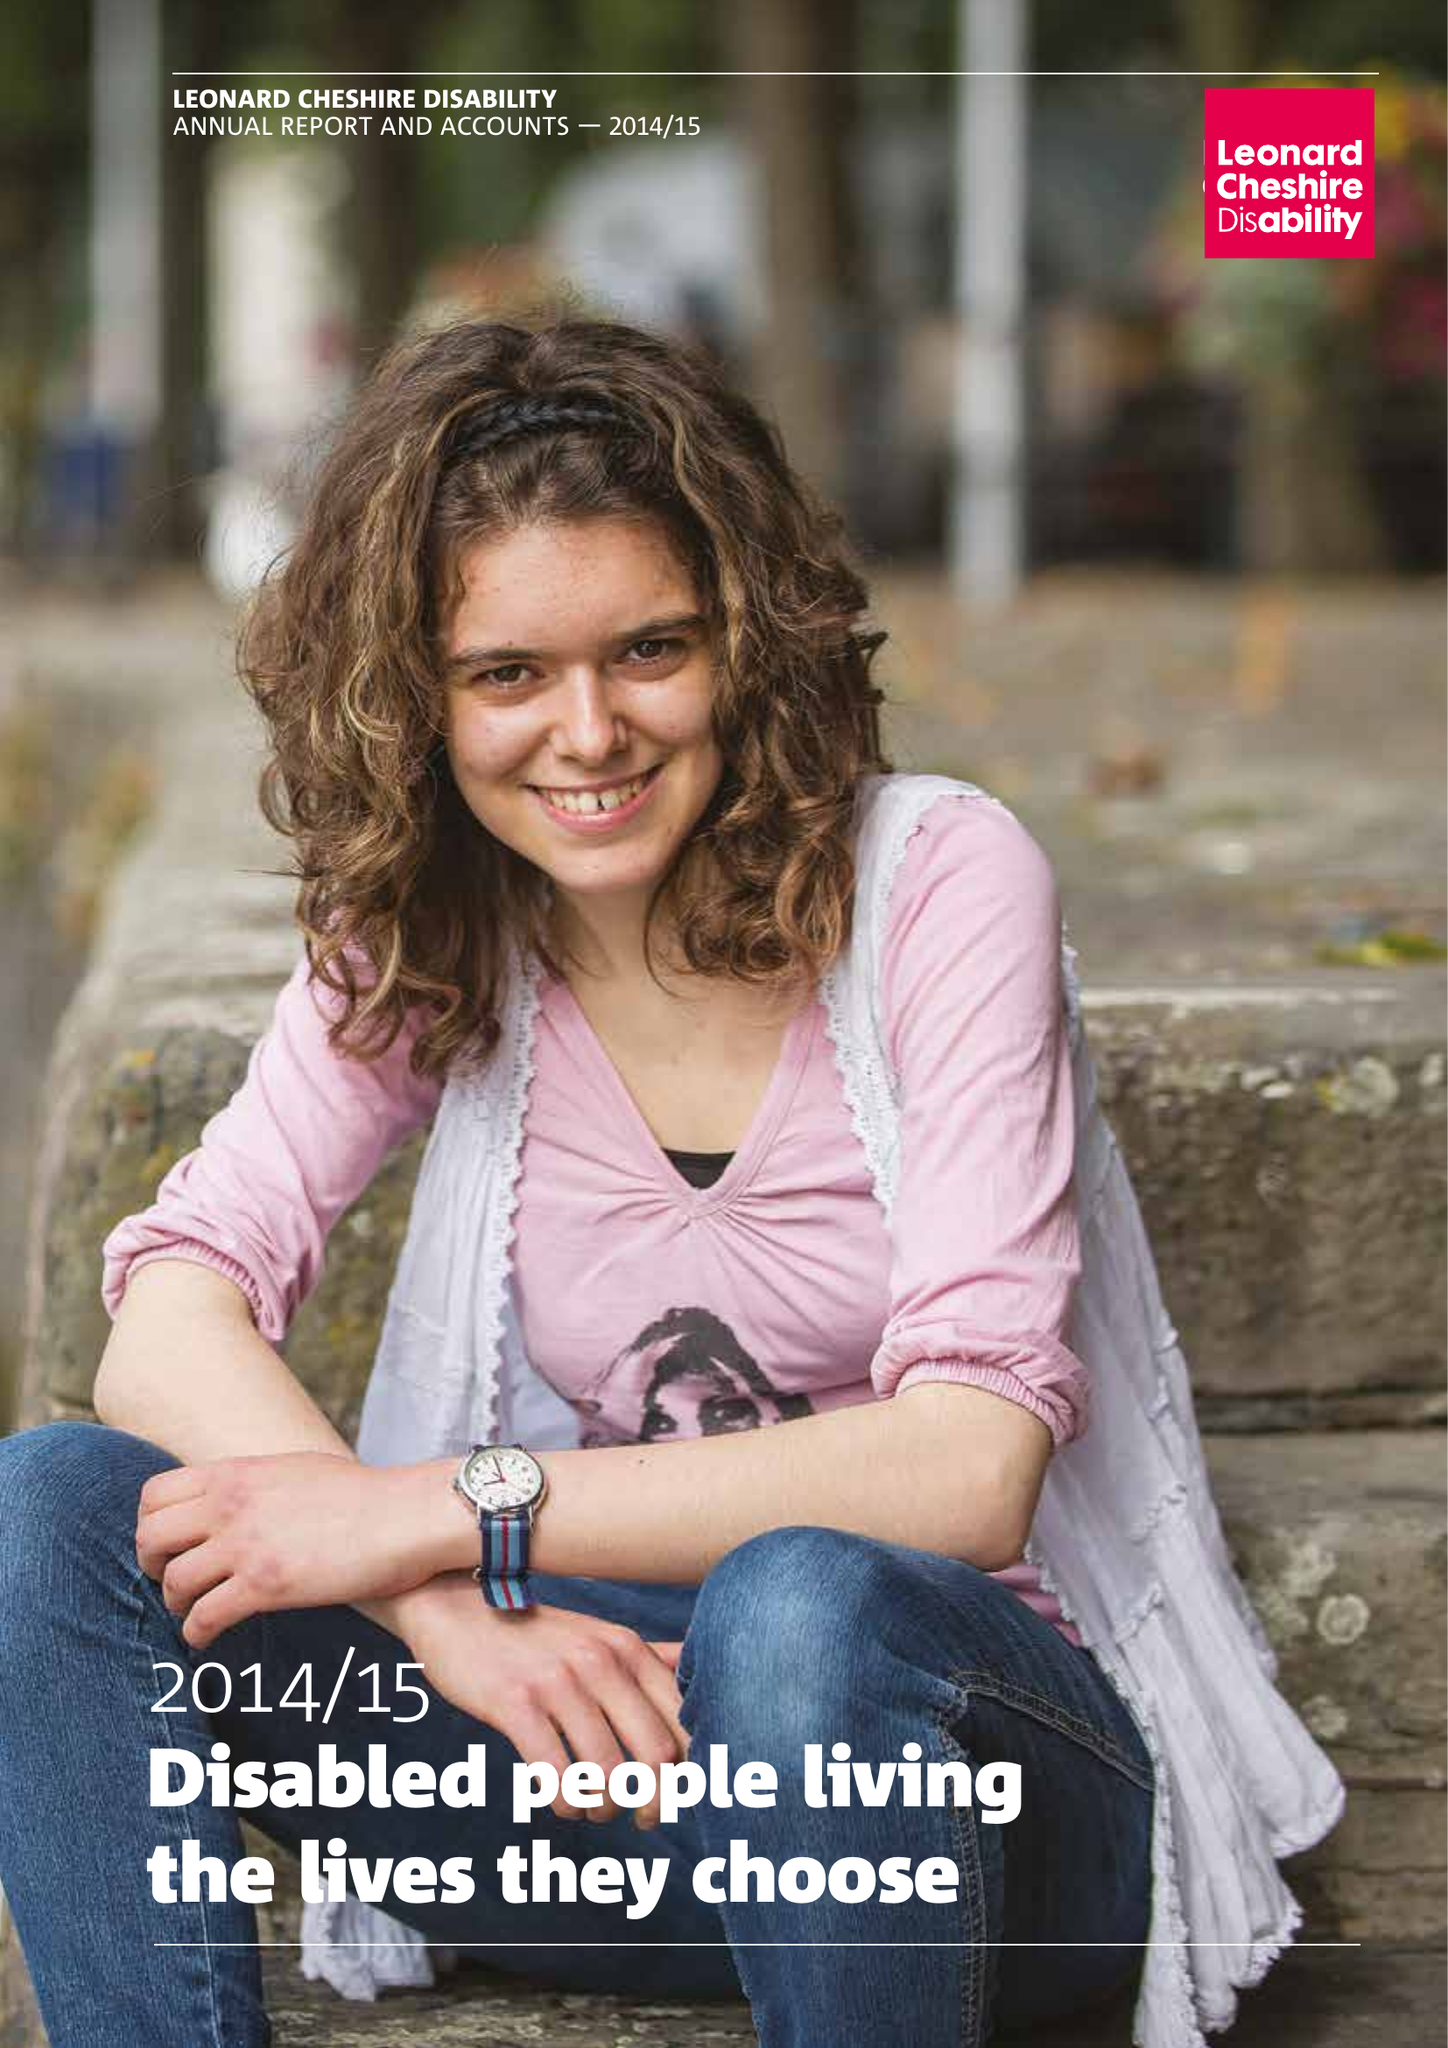What is the value for the charity_name?
Answer the question using a single word or phrase. Leonard Cheshire Disability Ltd. 